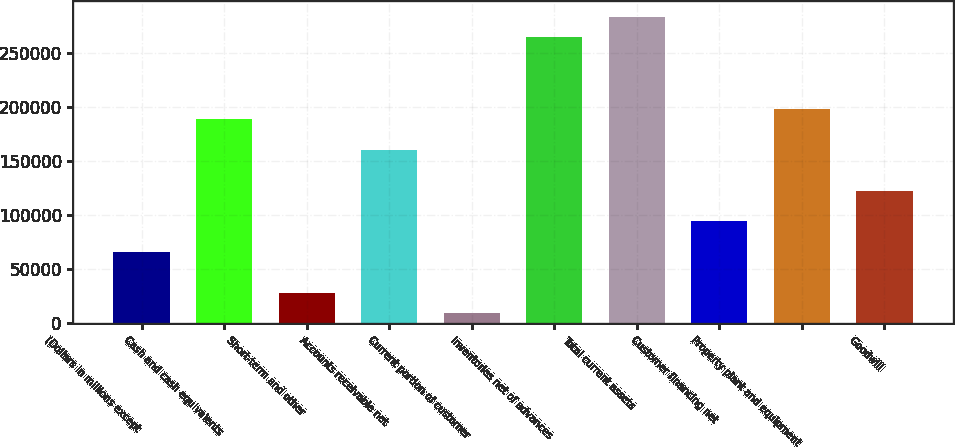Convert chart to OTSL. <chart><loc_0><loc_0><loc_500><loc_500><bar_chart><fcel>(Dollars in millions except<fcel>Cash and cash equivalents<fcel>Short-term and other<fcel>Accounts receivable net<fcel>Current portion of customer<fcel>Inventories net of advances<fcel>Total current assets<fcel>Customer financing net<fcel>Property plant and equipment<fcel>Goodwill<nl><fcel>66104.2<fcel>188754<fcel>28365.8<fcel>160450<fcel>9496.6<fcel>264231<fcel>283100<fcel>94408<fcel>198189<fcel>122712<nl></chart> 